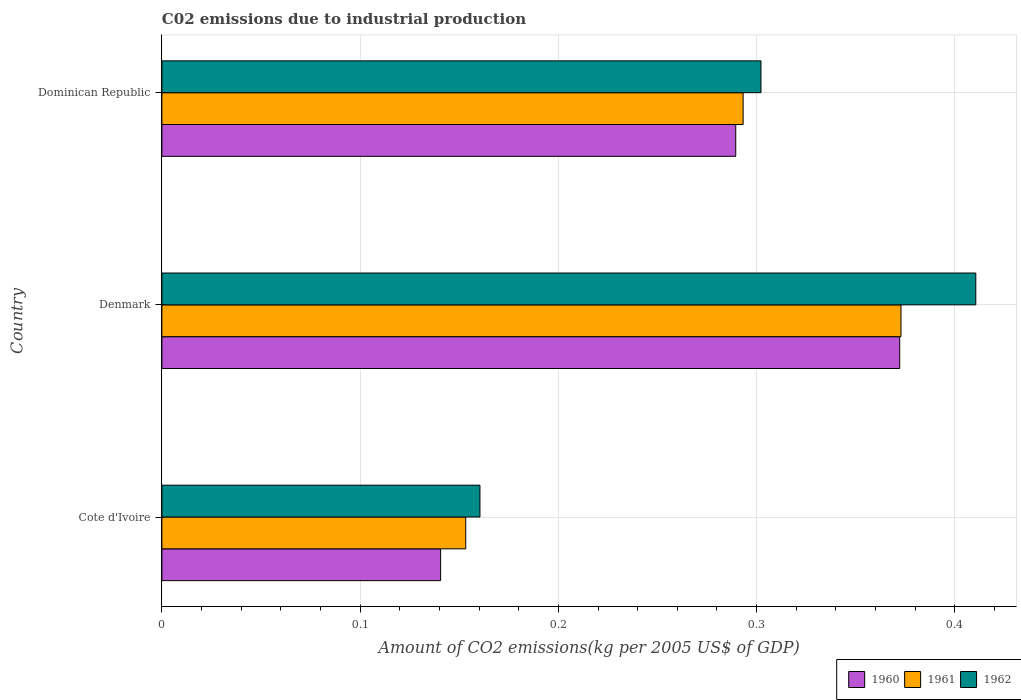How many groups of bars are there?
Ensure brevity in your answer.  3. What is the label of the 3rd group of bars from the top?
Your answer should be compact. Cote d'Ivoire. What is the amount of CO2 emitted due to industrial production in 1961 in Denmark?
Offer a terse response. 0.37. Across all countries, what is the maximum amount of CO2 emitted due to industrial production in 1961?
Make the answer very short. 0.37. Across all countries, what is the minimum amount of CO2 emitted due to industrial production in 1962?
Provide a short and direct response. 0.16. In which country was the amount of CO2 emitted due to industrial production in 1960 minimum?
Your answer should be very brief. Cote d'Ivoire. What is the total amount of CO2 emitted due to industrial production in 1961 in the graph?
Your answer should be compact. 0.82. What is the difference between the amount of CO2 emitted due to industrial production in 1962 in Denmark and that in Dominican Republic?
Provide a succinct answer. 0.11. What is the difference between the amount of CO2 emitted due to industrial production in 1960 in Denmark and the amount of CO2 emitted due to industrial production in 1961 in Dominican Republic?
Your answer should be very brief. 0.08. What is the average amount of CO2 emitted due to industrial production in 1962 per country?
Keep it short and to the point. 0.29. What is the difference between the amount of CO2 emitted due to industrial production in 1962 and amount of CO2 emitted due to industrial production in 1960 in Denmark?
Provide a succinct answer. 0.04. In how many countries, is the amount of CO2 emitted due to industrial production in 1962 greater than 0.30000000000000004 kg?
Ensure brevity in your answer.  2. What is the ratio of the amount of CO2 emitted due to industrial production in 1960 in Denmark to that in Dominican Republic?
Your answer should be very brief. 1.29. Is the amount of CO2 emitted due to industrial production in 1961 in Cote d'Ivoire less than that in Dominican Republic?
Make the answer very short. Yes. What is the difference between the highest and the second highest amount of CO2 emitted due to industrial production in 1960?
Make the answer very short. 0.08. What is the difference between the highest and the lowest amount of CO2 emitted due to industrial production in 1961?
Provide a succinct answer. 0.22. What does the 2nd bar from the bottom in Cote d'Ivoire represents?
Offer a very short reply. 1961. How many bars are there?
Your answer should be compact. 9. How many countries are there in the graph?
Keep it short and to the point. 3. How many legend labels are there?
Provide a succinct answer. 3. How are the legend labels stacked?
Keep it short and to the point. Horizontal. What is the title of the graph?
Your answer should be very brief. C02 emissions due to industrial production. What is the label or title of the X-axis?
Your answer should be very brief. Amount of CO2 emissions(kg per 2005 US$ of GDP). What is the Amount of CO2 emissions(kg per 2005 US$ of GDP) of 1960 in Cote d'Ivoire?
Ensure brevity in your answer.  0.14. What is the Amount of CO2 emissions(kg per 2005 US$ of GDP) in 1961 in Cote d'Ivoire?
Provide a succinct answer. 0.15. What is the Amount of CO2 emissions(kg per 2005 US$ of GDP) of 1962 in Cote d'Ivoire?
Provide a short and direct response. 0.16. What is the Amount of CO2 emissions(kg per 2005 US$ of GDP) in 1960 in Denmark?
Provide a short and direct response. 0.37. What is the Amount of CO2 emissions(kg per 2005 US$ of GDP) in 1961 in Denmark?
Provide a succinct answer. 0.37. What is the Amount of CO2 emissions(kg per 2005 US$ of GDP) in 1962 in Denmark?
Your response must be concise. 0.41. What is the Amount of CO2 emissions(kg per 2005 US$ of GDP) in 1960 in Dominican Republic?
Make the answer very short. 0.29. What is the Amount of CO2 emissions(kg per 2005 US$ of GDP) of 1961 in Dominican Republic?
Your answer should be very brief. 0.29. What is the Amount of CO2 emissions(kg per 2005 US$ of GDP) of 1962 in Dominican Republic?
Offer a terse response. 0.3. Across all countries, what is the maximum Amount of CO2 emissions(kg per 2005 US$ of GDP) in 1960?
Keep it short and to the point. 0.37. Across all countries, what is the maximum Amount of CO2 emissions(kg per 2005 US$ of GDP) in 1961?
Make the answer very short. 0.37. Across all countries, what is the maximum Amount of CO2 emissions(kg per 2005 US$ of GDP) in 1962?
Give a very brief answer. 0.41. Across all countries, what is the minimum Amount of CO2 emissions(kg per 2005 US$ of GDP) of 1960?
Offer a terse response. 0.14. Across all countries, what is the minimum Amount of CO2 emissions(kg per 2005 US$ of GDP) in 1961?
Keep it short and to the point. 0.15. Across all countries, what is the minimum Amount of CO2 emissions(kg per 2005 US$ of GDP) of 1962?
Offer a terse response. 0.16. What is the total Amount of CO2 emissions(kg per 2005 US$ of GDP) in 1960 in the graph?
Provide a succinct answer. 0.8. What is the total Amount of CO2 emissions(kg per 2005 US$ of GDP) in 1961 in the graph?
Offer a very short reply. 0.82. What is the total Amount of CO2 emissions(kg per 2005 US$ of GDP) of 1962 in the graph?
Ensure brevity in your answer.  0.87. What is the difference between the Amount of CO2 emissions(kg per 2005 US$ of GDP) of 1960 in Cote d'Ivoire and that in Denmark?
Provide a short and direct response. -0.23. What is the difference between the Amount of CO2 emissions(kg per 2005 US$ of GDP) in 1961 in Cote d'Ivoire and that in Denmark?
Offer a terse response. -0.22. What is the difference between the Amount of CO2 emissions(kg per 2005 US$ of GDP) in 1962 in Cote d'Ivoire and that in Denmark?
Offer a very short reply. -0.25. What is the difference between the Amount of CO2 emissions(kg per 2005 US$ of GDP) in 1960 in Cote d'Ivoire and that in Dominican Republic?
Your answer should be very brief. -0.15. What is the difference between the Amount of CO2 emissions(kg per 2005 US$ of GDP) in 1961 in Cote d'Ivoire and that in Dominican Republic?
Your response must be concise. -0.14. What is the difference between the Amount of CO2 emissions(kg per 2005 US$ of GDP) of 1962 in Cote d'Ivoire and that in Dominican Republic?
Ensure brevity in your answer.  -0.14. What is the difference between the Amount of CO2 emissions(kg per 2005 US$ of GDP) in 1960 in Denmark and that in Dominican Republic?
Your answer should be very brief. 0.08. What is the difference between the Amount of CO2 emissions(kg per 2005 US$ of GDP) in 1961 in Denmark and that in Dominican Republic?
Your answer should be compact. 0.08. What is the difference between the Amount of CO2 emissions(kg per 2005 US$ of GDP) in 1962 in Denmark and that in Dominican Republic?
Provide a short and direct response. 0.11. What is the difference between the Amount of CO2 emissions(kg per 2005 US$ of GDP) in 1960 in Cote d'Ivoire and the Amount of CO2 emissions(kg per 2005 US$ of GDP) in 1961 in Denmark?
Ensure brevity in your answer.  -0.23. What is the difference between the Amount of CO2 emissions(kg per 2005 US$ of GDP) of 1960 in Cote d'Ivoire and the Amount of CO2 emissions(kg per 2005 US$ of GDP) of 1962 in Denmark?
Your response must be concise. -0.27. What is the difference between the Amount of CO2 emissions(kg per 2005 US$ of GDP) in 1961 in Cote d'Ivoire and the Amount of CO2 emissions(kg per 2005 US$ of GDP) in 1962 in Denmark?
Provide a succinct answer. -0.26. What is the difference between the Amount of CO2 emissions(kg per 2005 US$ of GDP) in 1960 in Cote d'Ivoire and the Amount of CO2 emissions(kg per 2005 US$ of GDP) in 1961 in Dominican Republic?
Give a very brief answer. -0.15. What is the difference between the Amount of CO2 emissions(kg per 2005 US$ of GDP) of 1960 in Cote d'Ivoire and the Amount of CO2 emissions(kg per 2005 US$ of GDP) of 1962 in Dominican Republic?
Your response must be concise. -0.16. What is the difference between the Amount of CO2 emissions(kg per 2005 US$ of GDP) of 1961 in Cote d'Ivoire and the Amount of CO2 emissions(kg per 2005 US$ of GDP) of 1962 in Dominican Republic?
Your response must be concise. -0.15. What is the difference between the Amount of CO2 emissions(kg per 2005 US$ of GDP) in 1960 in Denmark and the Amount of CO2 emissions(kg per 2005 US$ of GDP) in 1961 in Dominican Republic?
Your answer should be compact. 0.08. What is the difference between the Amount of CO2 emissions(kg per 2005 US$ of GDP) in 1960 in Denmark and the Amount of CO2 emissions(kg per 2005 US$ of GDP) in 1962 in Dominican Republic?
Give a very brief answer. 0.07. What is the difference between the Amount of CO2 emissions(kg per 2005 US$ of GDP) in 1961 in Denmark and the Amount of CO2 emissions(kg per 2005 US$ of GDP) in 1962 in Dominican Republic?
Your answer should be very brief. 0.07. What is the average Amount of CO2 emissions(kg per 2005 US$ of GDP) in 1960 per country?
Ensure brevity in your answer.  0.27. What is the average Amount of CO2 emissions(kg per 2005 US$ of GDP) of 1961 per country?
Your response must be concise. 0.27. What is the average Amount of CO2 emissions(kg per 2005 US$ of GDP) of 1962 per country?
Give a very brief answer. 0.29. What is the difference between the Amount of CO2 emissions(kg per 2005 US$ of GDP) of 1960 and Amount of CO2 emissions(kg per 2005 US$ of GDP) of 1961 in Cote d'Ivoire?
Provide a succinct answer. -0.01. What is the difference between the Amount of CO2 emissions(kg per 2005 US$ of GDP) of 1960 and Amount of CO2 emissions(kg per 2005 US$ of GDP) of 1962 in Cote d'Ivoire?
Your response must be concise. -0.02. What is the difference between the Amount of CO2 emissions(kg per 2005 US$ of GDP) of 1961 and Amount of CO2 emissions(kg per 2005 US$ of GDP) of 1962 in Cote d'Ivoire?
Provide a succinct answer. -0.01. What is the difference between the Amount of CO2 emissions(kg per 2005 US$ of GDP) in 1960 and Amount of CO2 emissions(kg per 2005 US$ of GDP) in 1961 in Denmark?
Your response must be concise. -0. What is the difference between the Amount of CO2 emissions(kg per 2005 US$ of GDP) of 1960 and Amount of CO2 emissions(kg per 2005 US$ of GDP) of 1962 in Denmark?
Keep it short and to the point. -0.04. What is the difference between the Amount of CO2 emissions(kg per 2005 US$ of GDP) in 1961 and Amount of CO2 emissions(kg per 2005 US$ of GDP) in 1962 in Denmark?
Your answer should be compact. -0.04. What is the difference between the Amount of CO2 emissions(kg per 2005 US$ of GDP) in 1960 and Amount of CO2 emissions(kg per 2005 US$ of GDP) in 1961 in Dominican Republic?
Your response must be concise. -0. What is the difference between the Amount of CO2 emissions(kg per 2005 US$ of GDP) of 1960 and Amount of CO2 emissions(kg per 2005 US$ of GDP) of 1962 in Dominican Republic?
Provide a short and direct response. -0.01. What is the difference between the Amount of CO2 emissions(kg per 2005 US$ of GDP) of 1961 and Amount of CO2 emissions(kg per 2005 US$ of GDP) of 1962 in Dominican Republic?
Provide a short and direct response. -0.01. What is the ratio of the Amount of CO2 emissions(kg per 2005 US$ of GDP) of 1960 in Cote d'Ivoire to that in Denmark?
Your answer should be compact. 0.38. What is the ratio of the Amount of CO2 emissions(kg per 2005 US$ of GDP) in 1961 in Cote d'Ivoire to that in Denmark?
Your response must be concise. 0.41. What is the ratio of the Amount of CO2 emissions(kg per 2005 US$ of GDP) in 1962 in Cote d'Ivoire to that in Denmark?
Ensure brevity in your answer.  0.39. What is the ratio of the Amount of CO2 emissions(kg per 2005 US$ of GDP) of 1960 in Cote d'Ivoire to that in Dominican Republic?
Ensure brevity in your answer.  0.49. What is the ratio of the Amount of CO2 emissions(kg per 2005 US$ of GDP) in 1961 in Cote d'Ivoire to that in Dominican Republic?
Give a very brief answer. 0.52. What is the ratio of the Amount of CO2 emissions(kg per 2005 US$ of GDP) in 1962 in Cote d'Ivoire to that in Dominican Republic?
Provide a succinct answer. 0.53. What is the ratio of the Amount of CO2 emissions(kg per 2005 US$ of GDP) in 1960 in Denmark to that in Dominican Republic?
Ensure brevity in your answer.  1.29. What is the ratio of the Amount of CO2 emissions(kg per 2005 US$ of GDP) in 1961 in Denmark to that in Dominican Republic?
Make the answer very short. 1.27. What is the ratio of the Amount of CO2 emissions(kg per 2005 US$ of GDP) of 1962 in Denmark to that in Dominican Republic?
Ensure brevity in your answer.  1.36. What is the difference between the highest and the second highest Amount of CO2 emissions(kg per 2005 US$ of GDP) of 1960?
Give a very brief answer. 0.08. What is the difference between the highest and the second highest Amount of CO2 emissions(kg per 2005 US$ of GDP) of 1961?
Your answer should be very brief. 0.08. What is the difference between the highest and the second highest Amount of CO2 emissions(kg per 2005 US$ of GDP) in 1962?
Offer a terse response. 0.11. What is the difference between the highest and the lowest Amount of CO2 emissions(kg per 2005 US$ of GDP) of 1960?
Make the answer very short. 0.23. What is the difference between the highest and the lowest Amount of CO2 emissions(kg per 2005 US$ of GDP) in 1961?
Keep it short and to the point. 0.22. What is the difference between the highest and the lowest Amount of CO2 emissions(kg per 2005 US$ of GDP) in 1962?
Offer a very short reply. 0.25. 